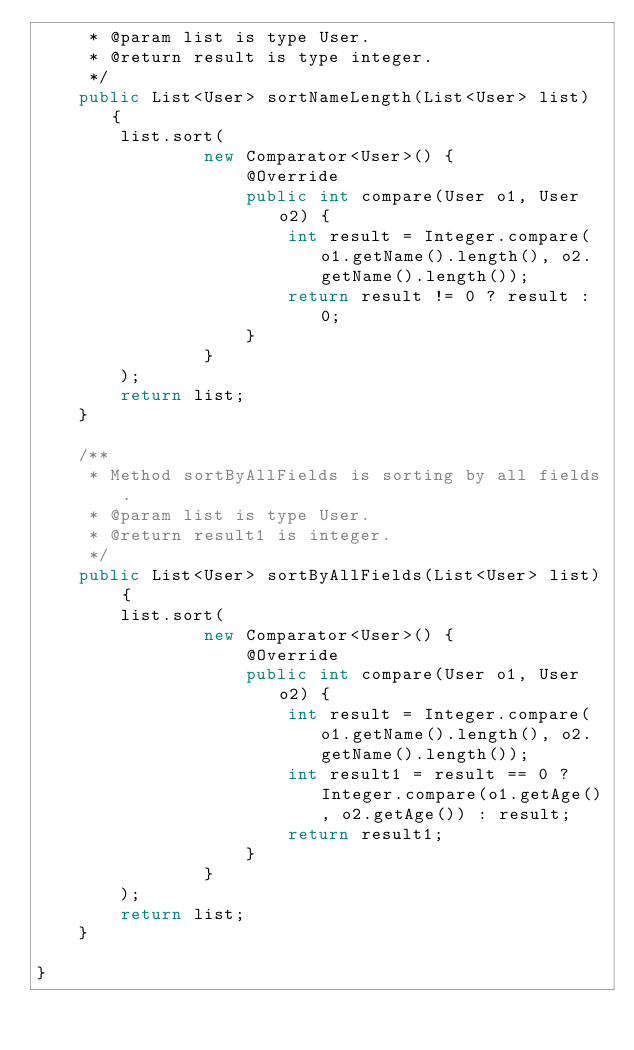Convert code to text. <code><loc_0><loc_0><loc_500><loc_500><_Java_>     * @param list is type User.
     * @return result is type integer.
     */
    public List<User> sortNameLength(List<User> list) {
        list.sort(
                new Comparator<User>() {
                    @Override
                    public int compare(User o1, User o2) {
                        int result = Integer.compare(o1.getName().length(), o2.getName().length());
                        return result != 0 ? result : 0;
                    }
                }
        );
        return list;
    }

    /**
     * Method sortByAllFields is sorting by all fields.
     * @param list is type User.
     * @return result1 is integer.
     */
    public List<User> sortByAllFields(List<User> list) {
        list.sort(
                new Comparator<User>() {
                    @Override
                    public int compare(User o1, User o2) {
                        int result = Integer.compare(o1.getName().length(), o2.getName().length());
                        int result1 = result == 0 ? Integer.compare(o1.getAge(), o2.getAge()) : result;
                        return result1;
                    }
                }
        );
        return list;
    }

}
</code> 